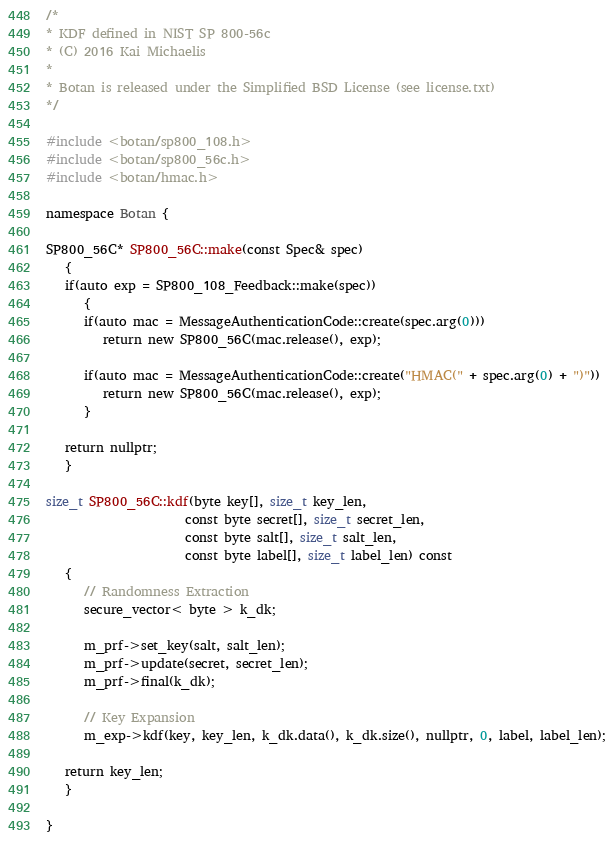<code> <loc_0><loc_0><loc_500><loc_500><_C++_>/*
* KDF defined in NIST SP 800-56c
* (C) 2016 Kai Michaelis
*
* Botan is released under the Simplified BSD License (see license.txt)
*/

#include <botan/sp800_108.h>
#include <botan/sp800_56c.h>
#include <botan/hmac.h>

namespace Botan {

SP800_56C* SP800_56C::make(const Spec& spec)
   {
   if(auto exp = SP800_108_Feedback::make(spec))
      {
      if(auto mac = MessageAuthenticationCode::create(spec.arg(0)))
         return new SP800_56C(mac.release(), exp);

      if(auto mac = MessageAuthenticationCode::create("HMAC(" + spec.arg(0) + ")"))
         return new SP800_56C(mac.release(), exp);
      }

   return nullptr;
   }

size_t SP800_56C::kdf(byte key[], size_t key_len,
                      const byte secret[], size_t secret_len,
                      const byte salt[], size_t salt_len,
                      const byte label[], size_t label_len) const
   {
      // Randomness Extraction
      secure_vector< byte > k_dk;

      m_prf->set_key(salt, salt_len);
      m_prf->update(secret, secret_len);
      m_prf->final(k_dk);

      // Key Expansion
      m_exp->kdf(key, key_len, k_dk.data(), k_dk.size(), nullptr, 0, label, label_len);

   return key_len;
   }

}
</code> 